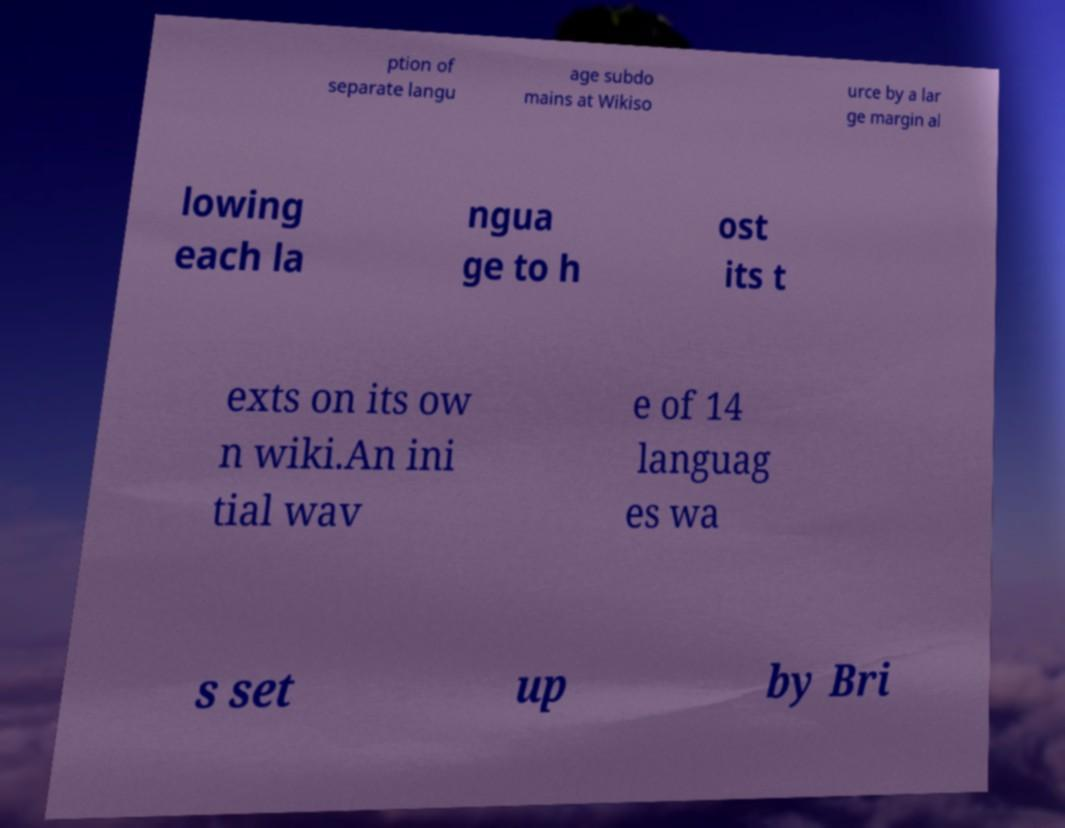Could you extract and type out the text from this image? ption of separate langu age subdo mains at Wikiso urce by a lar ge margin al lowing each la ngua ge to h ost its t exts on its ow n wiki.An ini tial wav e of 14 languag es wa s set up by Bri 